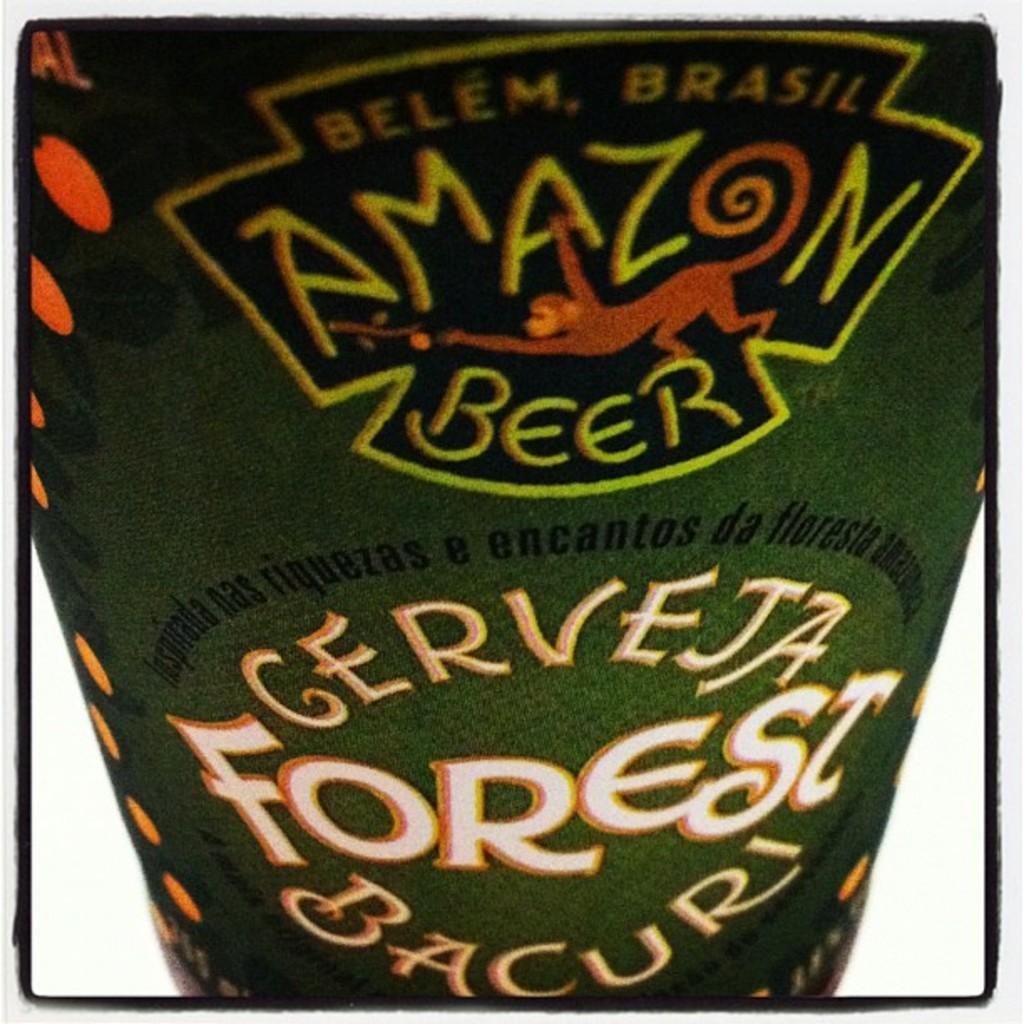In one or two sentences, can you explain what this image depicts? In the center of the image we can see a beverage. 